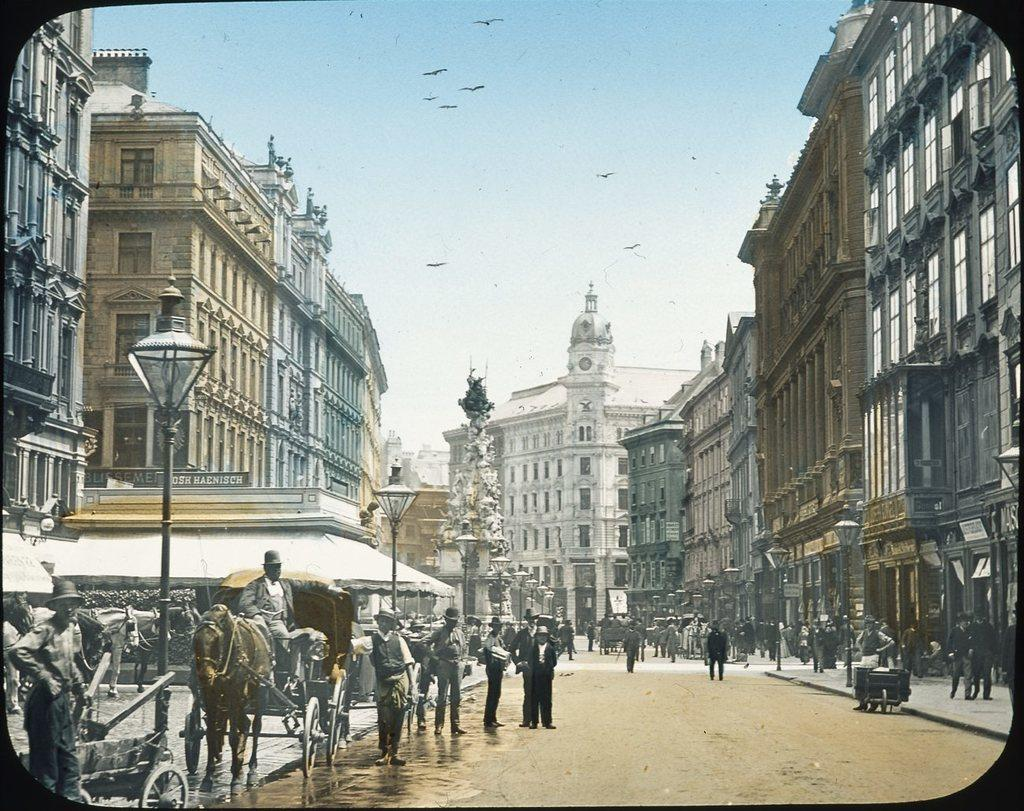What type of plant can be seen in the image? There is a tree in the image. What type of structures are visible in the image? There are buildings in the image. What objects provide illumination in the image? There are light poles in the image. What type of vehicle is present in the image? There is a cart in the image. What type of animal is present in the image? There is a horse in the image. Are there any human beings in the image? Yes, there are people in the image. What part of the natural environment is visible in the image? The sky is visible in the image. What type of living organisms are flying in the image? Birds are present in the image, and they are flying in the air. How much brain power is required to operate the cart in the image? The cart in the image does not require brain power to operate, as it is not an autonomous vehicle. What is the amount of low in the image? There is no reference to "low" in the image, so it cannot be quantified. 